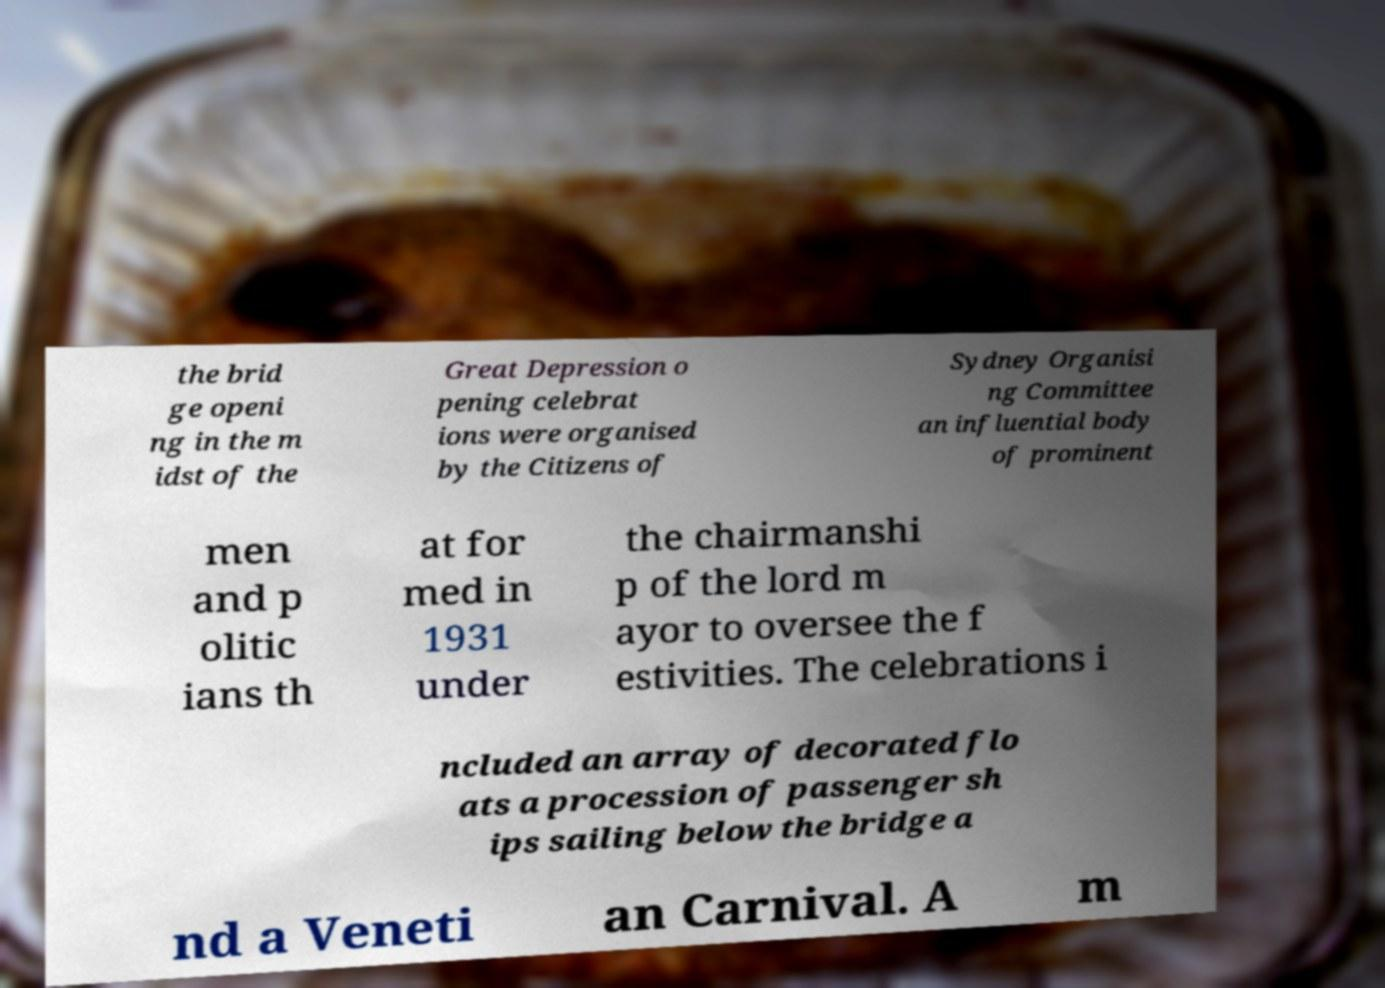Please identify and transcribe the text found in this image. the brid ge openi ng in the m idst of the Great Depression o pening celebrat ions were organised by the Citizens of Sydney Organisi ng Committee an influential body of prominent men and p olitic ians th at for med in 1931 under the chairmanshi p of the lord m ayor to oversee the f estivities. The celebrations i ncluded an array of decorated flo ats a procession of passenger sh ips sailing below the bridge a nd a Veneti an Carnival. A m 